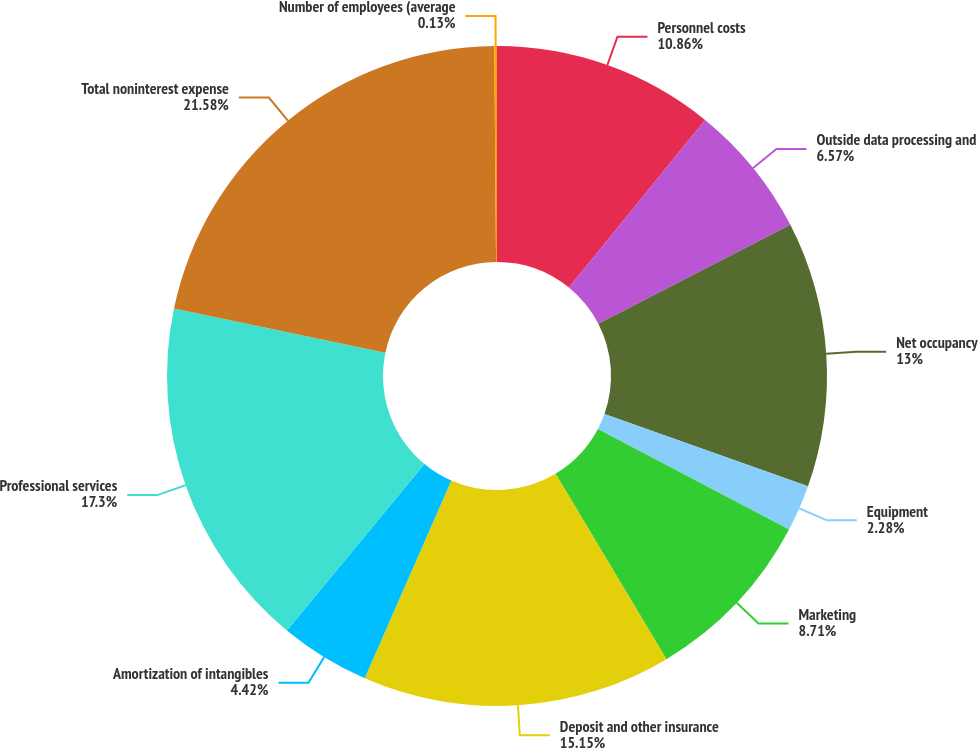Convert chart to OTSL. <chart><loc_0><loc_0><loc_500><loc_500><pie_chart><fcel>Personnel costs<fcel>Outside data processing and<fcel>Net occupancy<fcel>Equipment<fcel>Marketing<fcel>Deposit and other insurance<fcel>Amortization of intangibles<fcel>Professional services<fcel>Total noninterest expense<fcel>Number of employees (average<nl><fcel>10.86%<fcel>6.57%<fcel>13.0%<fcel>2.28%<fcel>8.71%<fcel>15.15%<fcel>4.42%<fcel>17.3%<fcel>21.59%<fcel>0.13%<nl></chart> 